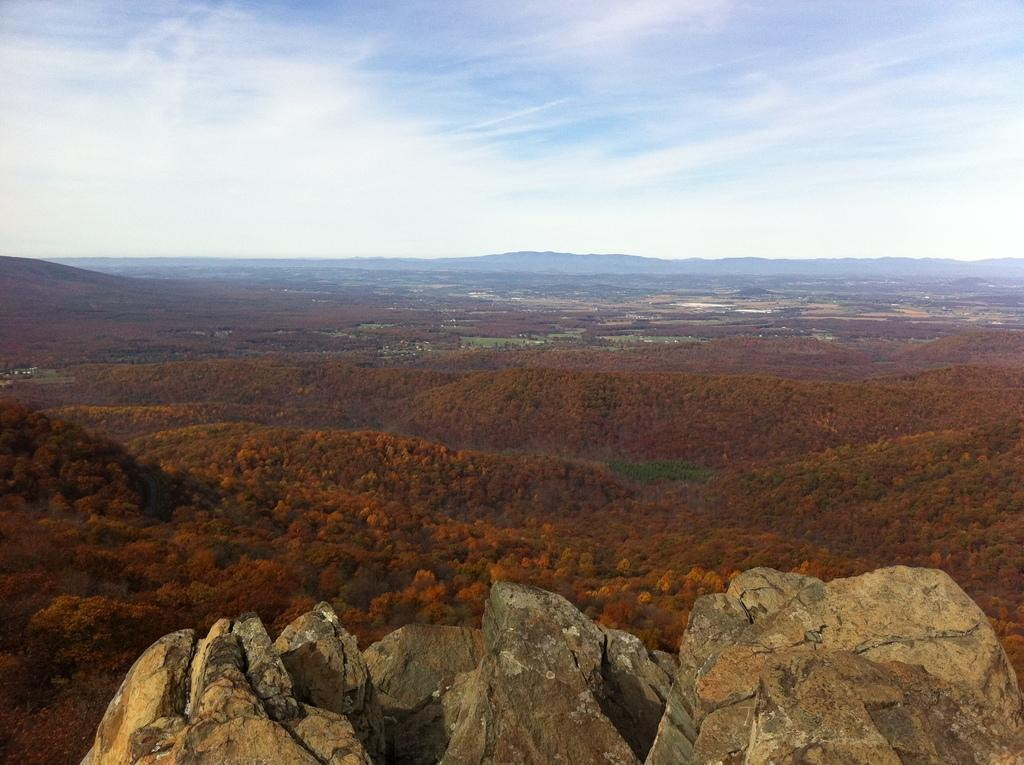What is located at the bottom of the image? There are rocks at the bottom of the image. What can be seen in the center of the image? There are trees in the center of the image. What type of geographical feature is visible in the background of the image? There are mountains in the background of the image. What is visible at the top of the image? The sky is visible at the top of the image. Can you tell me how many zippers are attached to the trees in the image? There are no zippers present on the trees in the image. What type of wax is being used to create the mountains in the background? There is no wax used to create the mountains in the image; they are natural geographical features. 